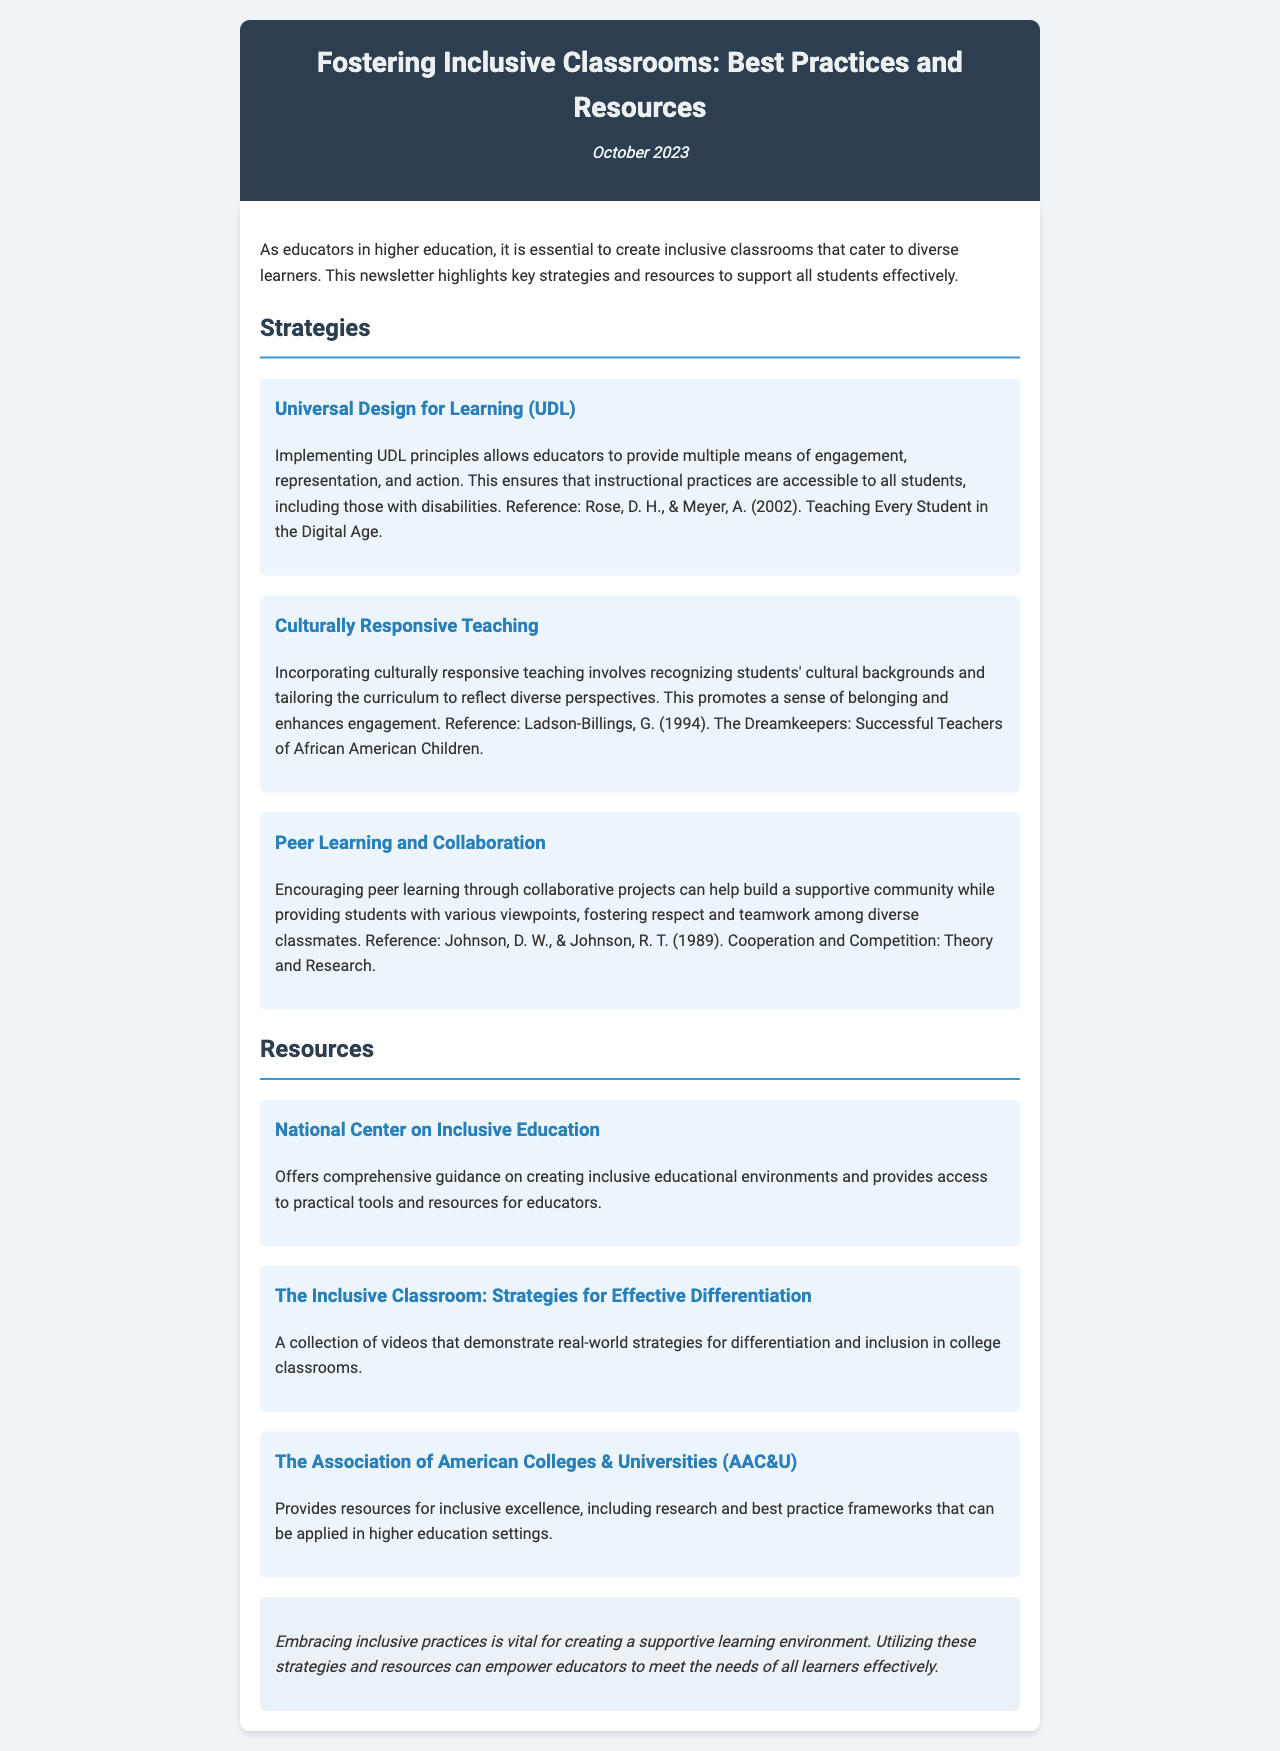What is the title of the newsletter? The title is presented at the top of the document and highlights the focus on inclusive classrooms.
Answer: Fostering Inclusive Classrooms: Best Practices and Resources When was the newsletter published? The publication date is stated in the header section of the document.
Answer: October 2023 What strategy involves recognizing students' cultural backgrounds? The strategy is explicitly mentioned in the content section that discusses tailoring the curriculum to reflect diverse perspectives.
Answer: Culturally Responsive Teaching Which resource offers comprehensive guidance on creating inclusive educational environments? The resource name is found under the Resources section, indicating its purpose clearly.
Answer: National Center on Inclusive Education What is one principle of Universal Design for Learning (UDL)? The principles are listed, detailing how to make instructional practices accessible to all students.
Answer: Multiple means of engagement What kind of projects does Peer Learning and Collaboration encourage? The projects mentioned aim to build a supportive community among students.
Answer: Collaborative projects How many strategies are highlighted in the document? The document outlines several strategies for fostering inclusive classrooms.
Answer: Three Who are the authors of the UDL reference mentioned? The authors are listed under the UDL strategy along with their publication year, indicating the source of the information.
Answer: Rose, D. H., & Meyer, A What is the purpose of the Association of American Colleges & Universities (AAC&U)? The document describes the AAC&U's role in providing resources for inclusive excellence.
Answer: Resources for inclusive excellence 